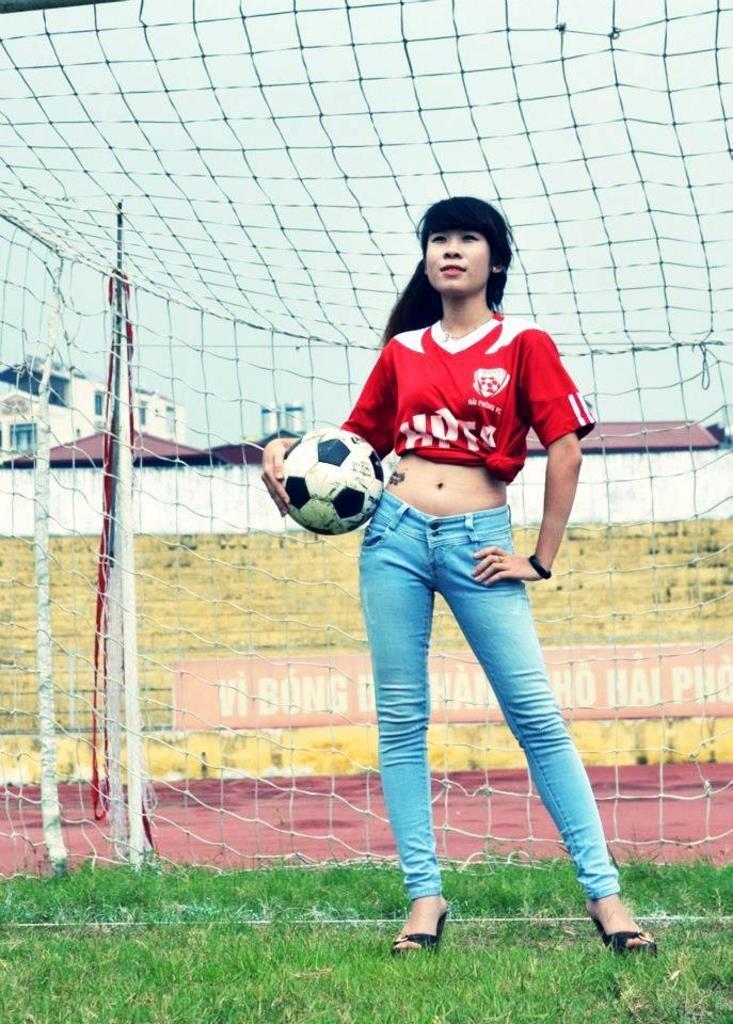Please provide a concise description of this image. There is a woman standing and holding a ball and we can see grass and net, through this net we can see grass, banner, houses, pole, wall and sky. 